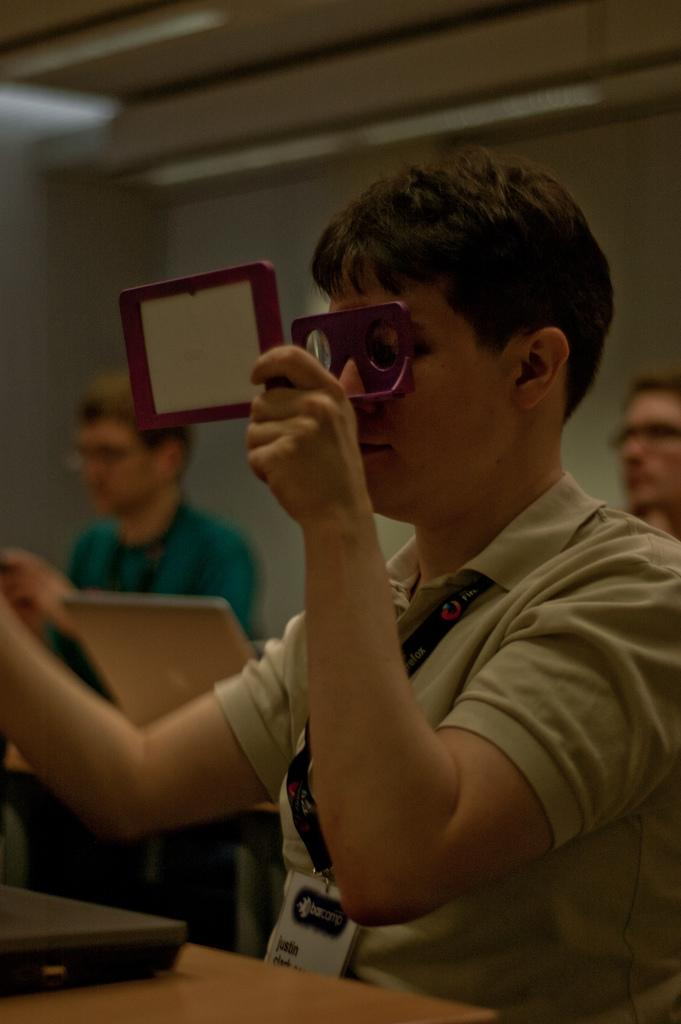What is the man in the image wearing? The man is wearing an ID card. What is the man holding in his hand? The man is holding an object in his hand. What type of electronic devices can be seen in the image? There are laptops and tablets in the image. How many people are visible in the background of the image? There are two people in the background of the image. What is present in the background of the image? There is a wall in the background of the image. What type of feather can be seen in the image? There is no feather present in the image. What is the man learning in the image? The image does not provide information about what the man is learning. 